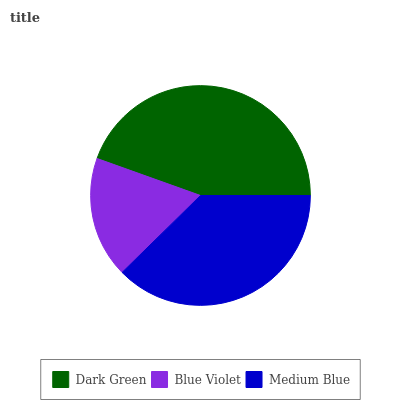Is Blue Violet the minimum?
Answer yes or no. Yes. Is Dark Green the maximum?
Answer yes or no. Yes. Is Medium Blue the minimum?
Answer yes or no. No. Is Medium Blue the maximum?
Answer yes or no. No. Is Medium Blue greater than Blue Violet?
Answer yes or no. Yes. Is Blue Violet less than Medium Blue?
Answer yes or no. Yes. Is Blue Violet greater than Medium Blue?
Answer yes or no. No. Is Medium Blue less than Blue Violet?
Answer yes or no. No. Is Medium Blue the high median?
Answer yes or no. Yes. Is Medium Blue the low median?
Answer yes or no. Yes. Is Blue Violet the high median?
Answer yes or no. No. Is Blue Violet the low median?
Answer yes or no. No. 